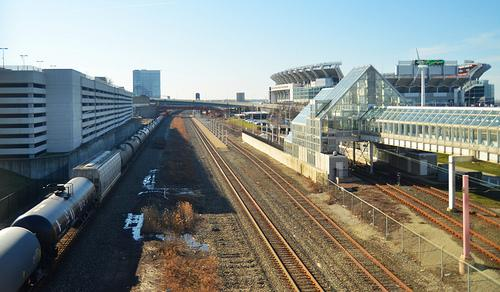In the context of the image, determine what is found between the tracks. Pools of standing water and small puddles. Using visual information, enumerate two types of transportation facilities in the image. A roadway bridge over the railroad tracks and a multi-level parking lot. Assess the image sentiment based on the presence of the clear sky. The sentiment is likely positive, as a clear sky often implies good weather and a pleasant atmosphere. Describe the state of the sky in the image. The sky is clear. List three types of buildings seen in the image. A new glass enclosed monorail terminal, a tall office building, and a sports stadium. How many lamp posts can be found in the passenger platform in the image? Many lamp posts. What is the common feature shared by the objects in the first 9 image? Small puddles of water behind the tracks. What is the purpose of the pink pole in the image? No discernable purpose. Identify the type of train in the image. A freight train made up mostly of tanker cars. Explain the presence of standing water in the image. There are small puddles and pools of standing water located between and behind the train tracks. 